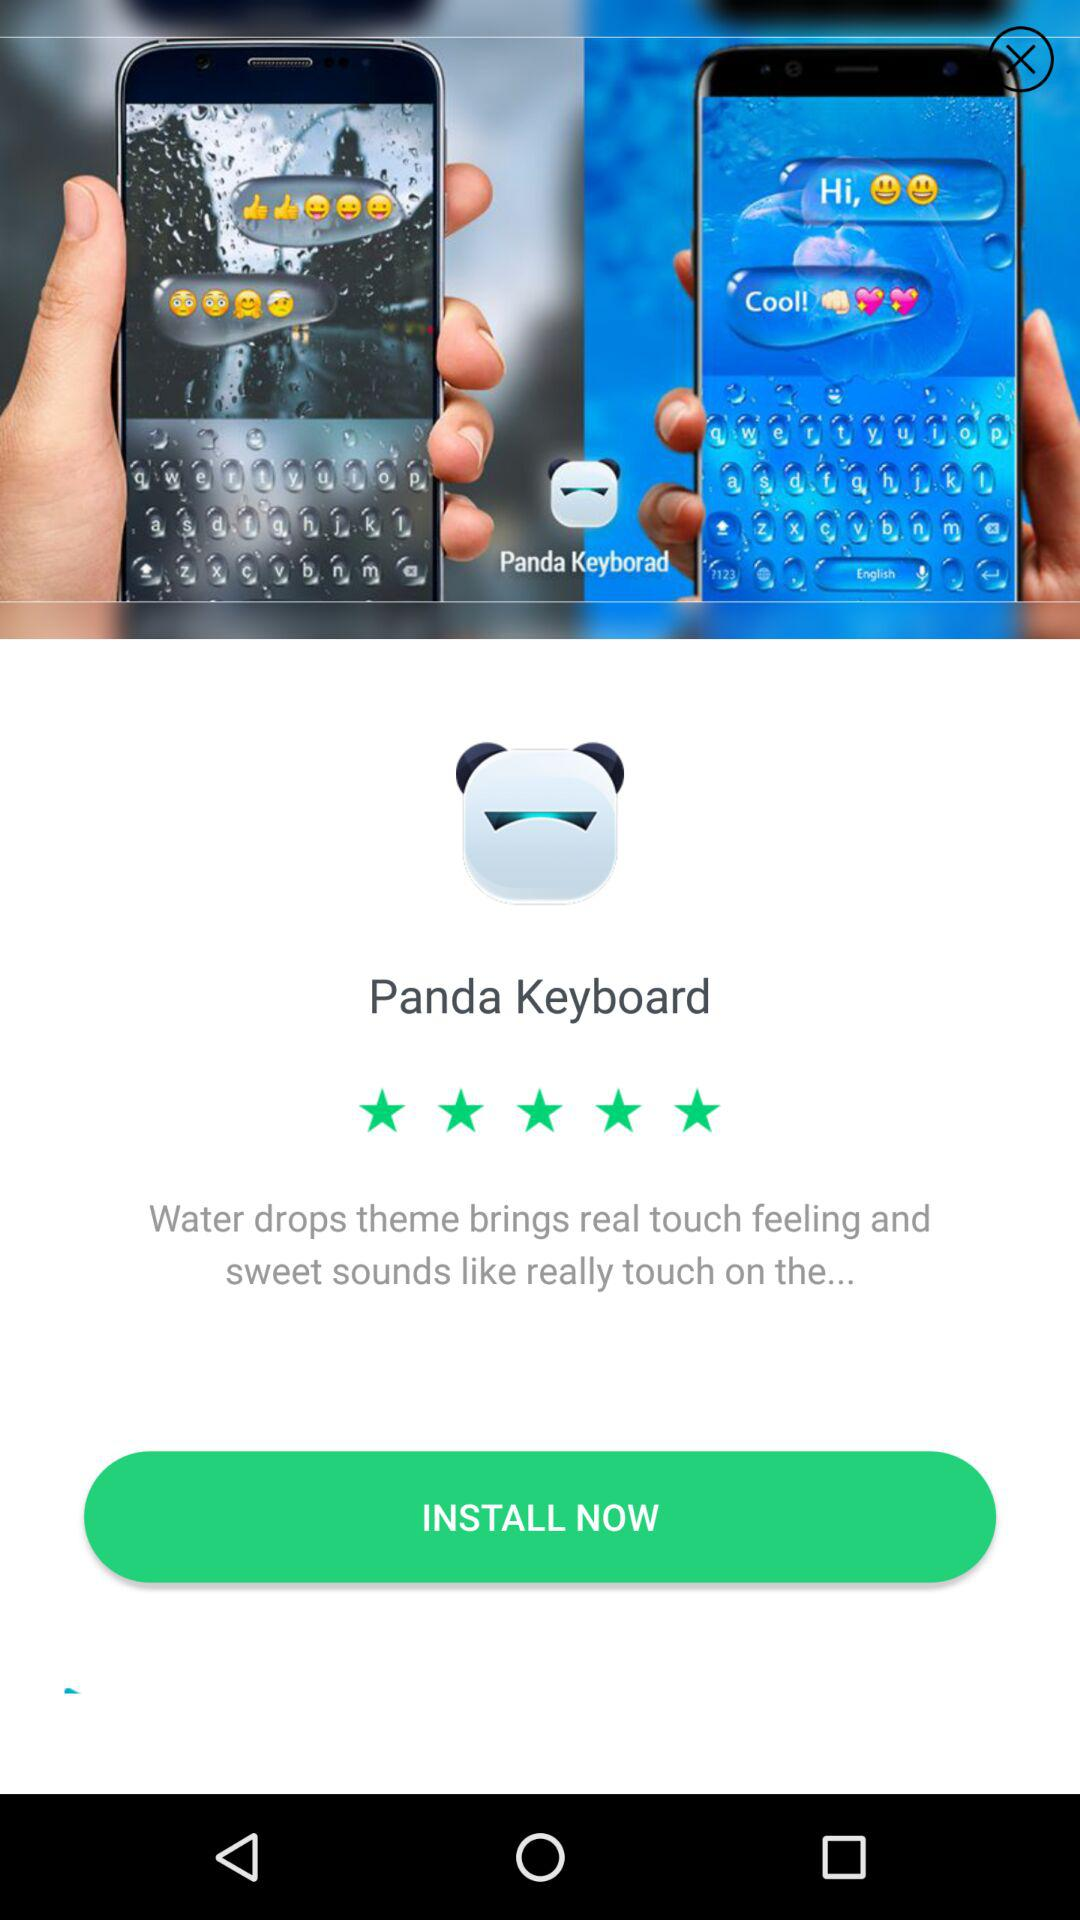What theme brings a real touch feeling? The theme is "Water drops theme". 